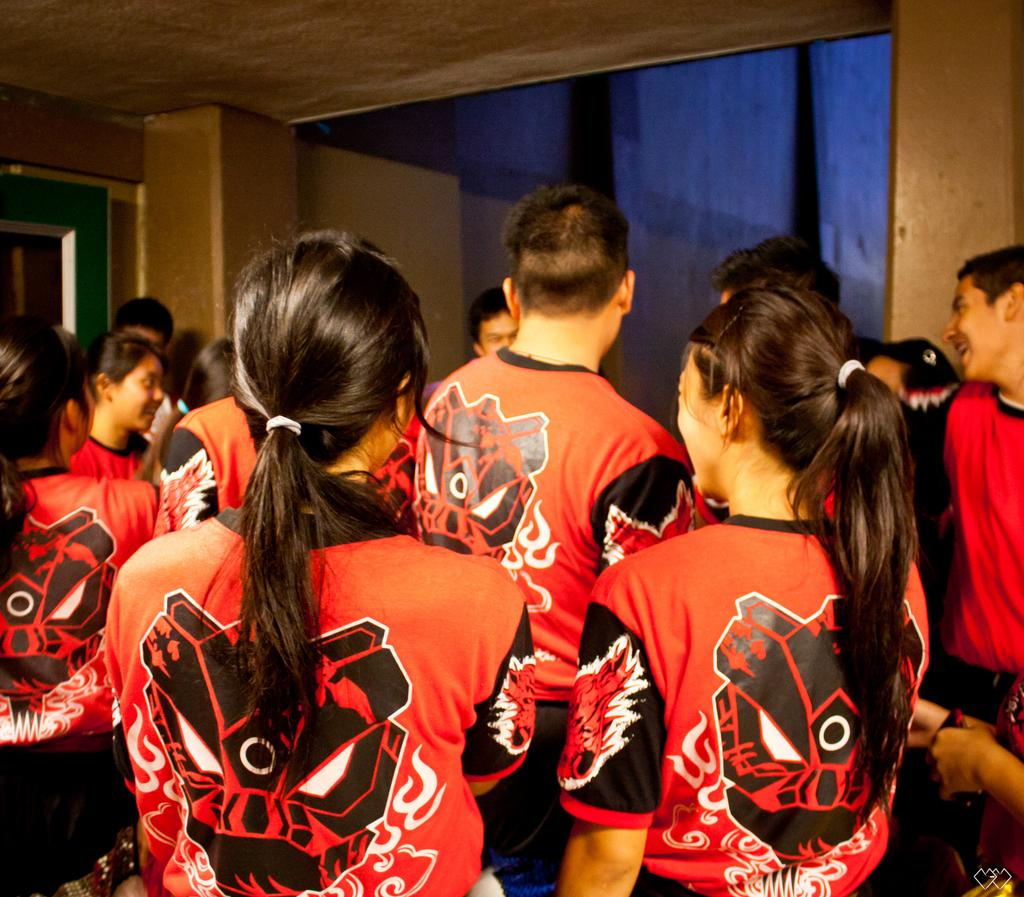How many people are in the room? There are people in the room, but the exact number is not specified. What are the people wearing? The people are wearing the same dress, except for one person who is wearing a red top. Can you describe the person wearing the red top? There is a person in the room wearing a red top, while the others are wearing the same dress. What type of ray can be seen swimming in the room? There is no ray present in the room; the image features people wearing clothing. What fruit is being served on a plate in the room? The facts provided do not mention any fruit or plates in the room. 